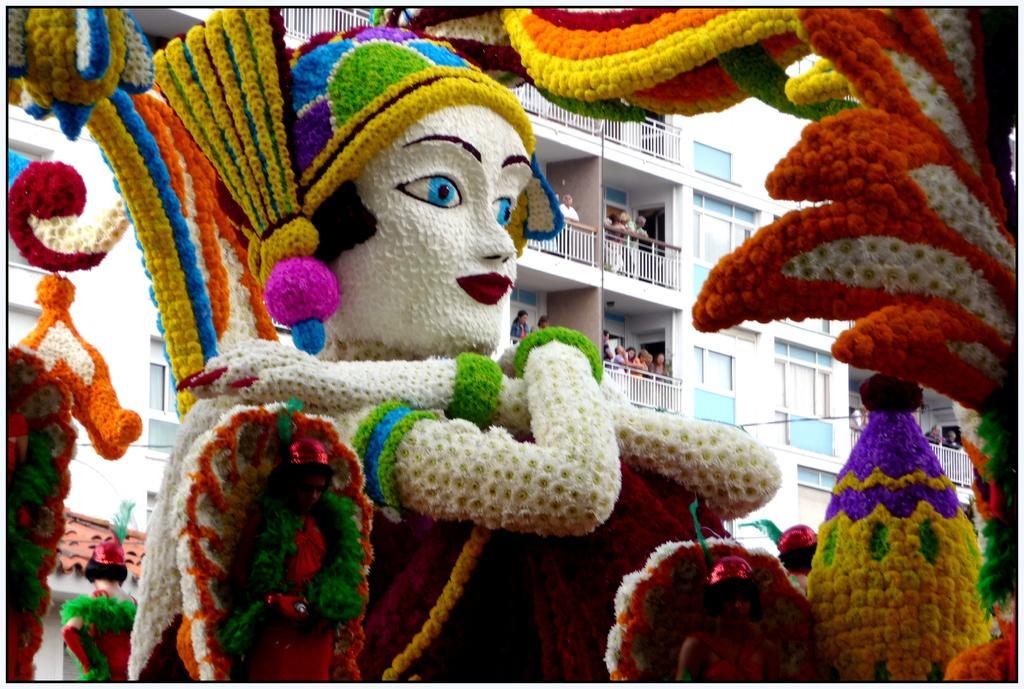Describe this image in one or two sentences. In this picture there are buildings and there are group of people standing behind the railings. In the foreground there is an artificial woman and there are flowers. At the bottom left there are roof tiles on the building. 